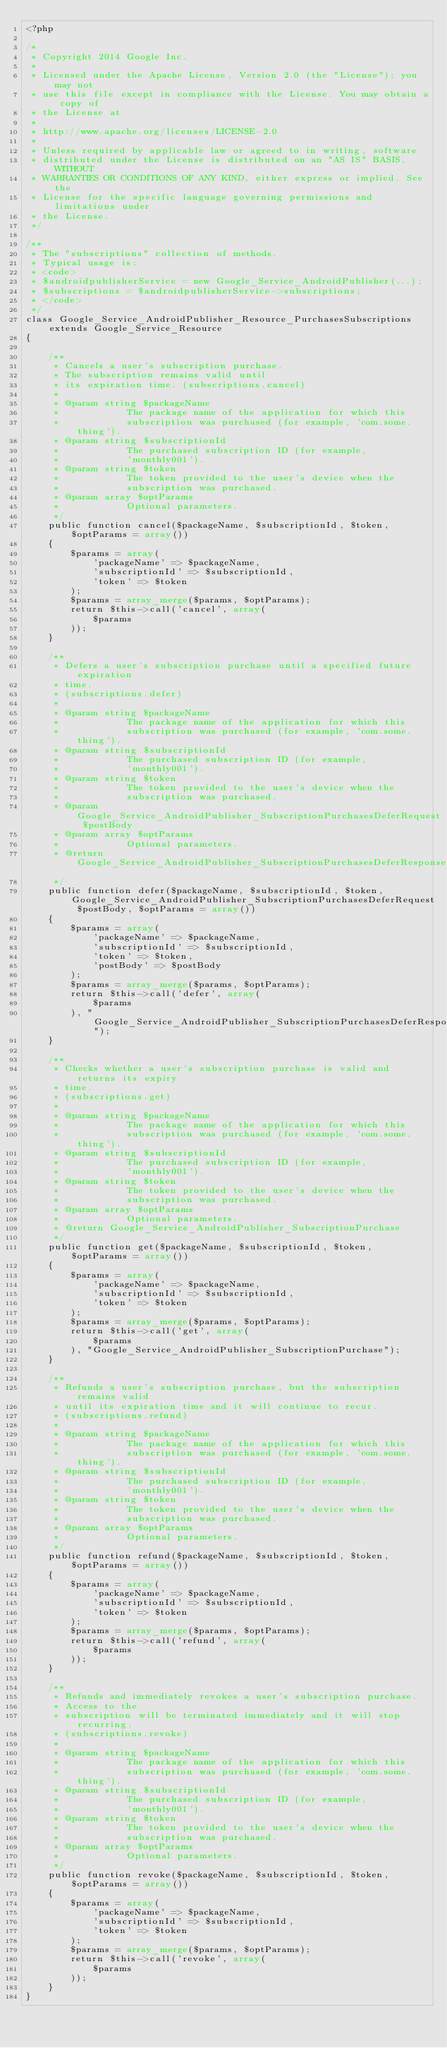<code> <loc_0><loc_0><loc_500><loc_500><_PHP_><?php

/*
 * Copyright 2014 Google Inc.
 *
 * Licensed under the Apache License, Version 2.0 (the "License"); you may not
 * use this file except in compliance with the License. You may obtain a copy of
 * the License at
 *
 * http://www.apache.org/licenses/LICENSE-2.0
 *
 * Unless required by applicable law or agreed to in writing, software
 * distributed under the License is distributed on an "AS IS" BASIS, WITHOUT
 * WARRANTIES OR CONDITIONS OF ANY KIND, either express or implied. See the
 * License for the specific language governing permissions and limitations under
 * the License.
 */

/**
 * The "subscriptions" collection of methods.
 * Typical usage is:
 * <code>
 * $androidpublisherService = new Google_Service_AndroidPublisher(...);
 * $subscriptions = $androidpublisherService->subscriptions;
 * </code>
 */
class Google_Service_AndroidPublisher_Resource_PurchasesSubscriptions extends Google_Service_Resource
{

    /**
     * Cancels a user's subscription purchase.
     * The subscription remains valid until
     * its expiration time. (subscriptions.cancel)
     *
     * @param string $packageName
     *            The package name of the application for which this
     *            subscription was purchased (for example, 'com.some.thing').
     * @param string $subscriptionId
     *            The purchased subscription ID (for example,
     *            'monthly001').
     * @param string $token
     *            The token provided to the user's device when the
     *            subscription was purchased.
     * @param array $optParams
     *            Optional parameters.
     */
    public function cancel($packageName, $subscriptionId, $token, $optParams = array())
    {
        $params = array(
            'packageName' => $packageName,
            'subscriptionId' => $subscriptionId,
            'token' => $token
        );
        $params = array_merge($params, $optParams);
        return $this->call('cancel', array(
            $params
        ));
    }

    /**
     * Defers a user's subscription purchase until a specified future expiration
     * time.
     * (subscriptions.defer)
     *
     * @param string $packageName
     *            The package name of the application for which this
     *            subscription was purchased (for example, 'com.some.thing').
     * @param string $subscriptionId
     *            The purchased subscription ID (for example,
     *            'monthly001').
     * @param string $token
     *            The token provided to the user's device when the
     *            subscription was purchased.
     * @param Google_Service_AndroidPublisher_SubscriptionPurchasesDeferRequest $postBody
     * @param array $optParams
     *            Optional parameters.
     * @return Google_Service_AndroidPublisher_SubscriptionPurchasesDeferResponse
     */
    public function defer($packageName, $subscriptionId, $token, Google_Service_AndroidPublisher_SubscriptionPurchasesDeferRequest $postBody, $optParams = array())
    {
        $params = array(
            'packageName' => $packageName,
            'subscriptionId' => $subscriptionId,
            'token' => $token,
            'postBody' => $postBody
        );
        $params = array_merge($params, $optParams);
        return $this->call('defer', array(
            $params
        ), "Google_Service_AndroidPublisher_SubscriptionPurchasesDeferResponse");
    }

    /**
     * Checks whether a user's subscription purchase is valid and returns its expiry
     * time.
     * (subscriptions.get)
     *
     * @param string $packageName
     *            The package name of the application for which this
     *            subscription was purchased (for example, 'com.some.thing').
     * @param string $subscriptionId
     *            The purchased subscription ID (for example,
     *            'monthly001').
     * @param string $token
     *            The token provided to the user's device when the
     *            subscription was purchased.
     * @param array $optParams
     *            Optional parameters.
     * @return Google_Service_AndroidPublisher_SubscriptionPurchase
     */
    public function get($packageName, $subscriptionId, $token, $optParams = array())
    {
        $params = array(
            'packageName' => $packageName,
            'subscriptionId' => $subscriptionId,
            'token' => $token
        );
        $params = array_merge($params, $optParams);
        return $this->call('get', array(
            $params
        ), "Google_Service_AndroidPublisher_SubscriptionPurchase");
    }

    /**
     * Refunds a user's subscription purchase, but the subscription remains valid
     * until its expiration time and it will continue to recur.
     * (subscriptions.refund)
     *
     * @param string $packageName
     *            The package name of the application for which this
     *            subscription was purchased (for example, 'com.some.thing').
     * @param string $subscriptionId
     *            The purchased subscription ID (for example,
     *            'monthly001').
     * @param string $token
     *            The token provided to the user's device when the
     *            subscription was purchased.
     * @param array $optParams
     *            Optional parameters.
     */
    public function refund($packageName, $subscriptionId, $token, $optParams = array())
    {
        $params = array(
            'packageName' => $packageName,
            'subscriptionId' => $subscriptionId,
            'token' => $token
        );
        $params = array_merge($params, $optParams);
        return $this->call('refund', array(
            $params
        ));
    }

    /**
     * Refunds and immediately revokes a user's subscription purchase.
     * Access to the
     * subscription will be terminated immediately and it will stop recurring.
     * (subscriptions.revoke)
     *
     * @param string $packageName
     *            The package name of the application for which this
     *            subscription was purchased (for example, 'com.some.thing').
     * @param string $subscriptionId
     *            The purchased subscription ID (for example,
     *            'monthly001').
     * @param string $token
     *            The token provided to the user's device when the
     *            subscription was purchased.
     * @param array $optParams
     *            Optional parameters.
     */
    public function revoke($packageName, $subscriptionId, $token, $optParams = array())
    {
        $params = array(
            'packageName' => $packageName,
            'subscriptionId' => $subscriptionId,
            'token' => $token
        );
        $params = array_merge($params, $optParams);
        return $this->call('revoke', array(
            $params
        ));
    }
}
</code> 